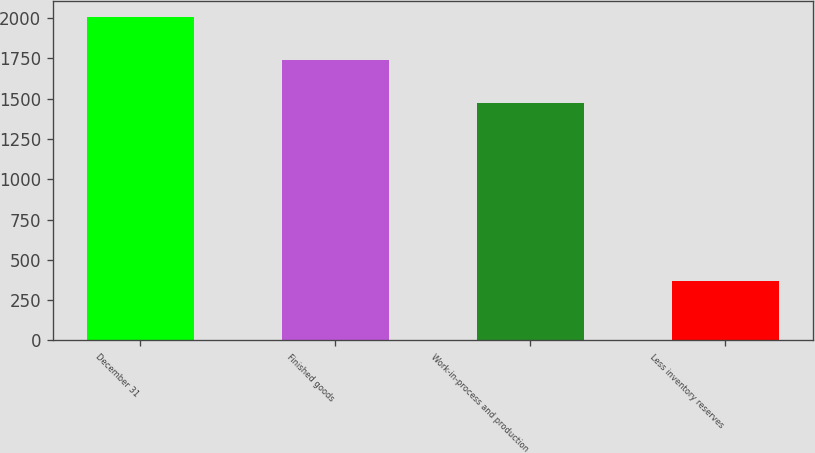Convert chart. <chart><loc_0><loc_0><loc_500><loc_500><bar_chart><fcel>December 31<fcel>Finished goods<fcel>Work-in-process and production<fcel>Less inventory reserves<nl><fcel>2007<fcel>1737<fcel>1470<fcel>371<nl></chart> 